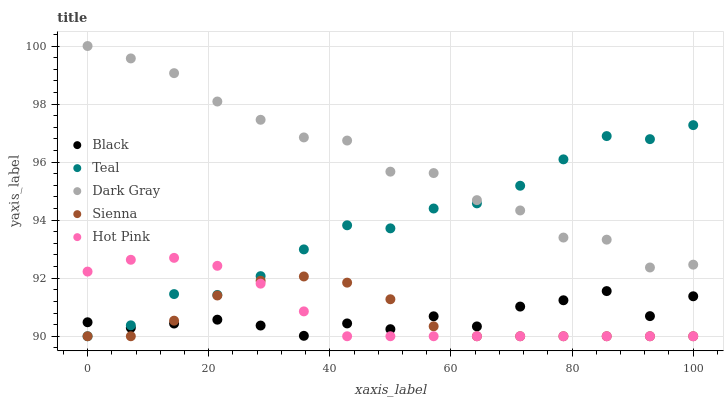Does Black have the minimum area under the curve?
Answer yes or no. Yes. Does Dark Gray have the maximum area under the curve?
Answer yes or no. Yes. Does Sienna have the minimum area under the curve?
Answer yes or no. No. Does Sienna have the maximum area under the curve?
Answer yes or no. No. Is Hot Pink the smoothest?
Answer yes or no. Yes. Is Dark Gray the roughest?
Answer yes or no. Yes. Is Sienna the smoothest?
Answer yes or no. No. Is Sienna the roughest?
Answer yes or no. No. Does Sienna have the lowest value?
Answer yes or no. Yes. Does Black have the lowest value?
Answer yes or no. No. Does Dark Gray have the highest value?
Answer yes or no. Yes. Does Sienna have the highest value?
Answer yes or no. No. Is Black less than Dark Gray?
Answer yes or no. Yes. Is Dark Gray greater than Sienna?
Answer yes or no. Yes. Does Teal intersect Sienna?
Answer yes or no. Yes. Is Teal less than Sienna?
Answer yes or no. No. Is Teal greater than Sienna?
Answer yes or no. No. Does Black intersect Dark Gray?
Answer yes or no. No. 